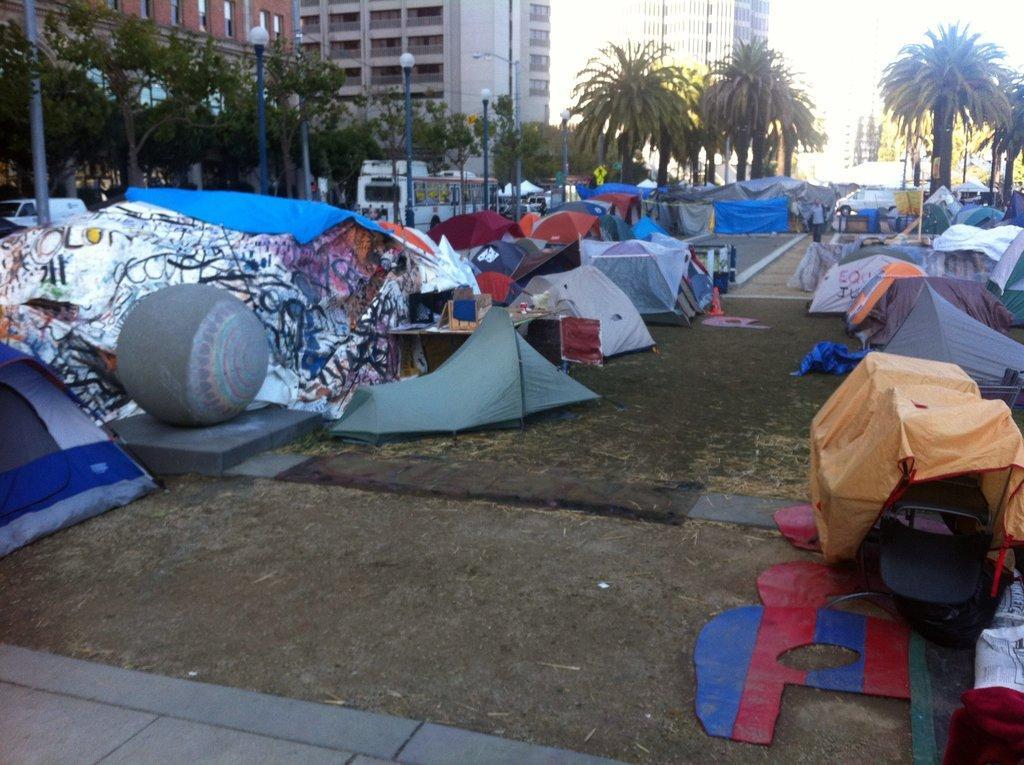Could you give a brief overview of what you see in this image? In this image, I can see the tents. This looks like a table with a cardboard box. I think this is the sculpture of a ball, which is placed on the stone. These are the streetlights. I can see a bus and a van on the road. These are the trees. I can see the buildings with windows. This looks like a flag hanging to the pole. 